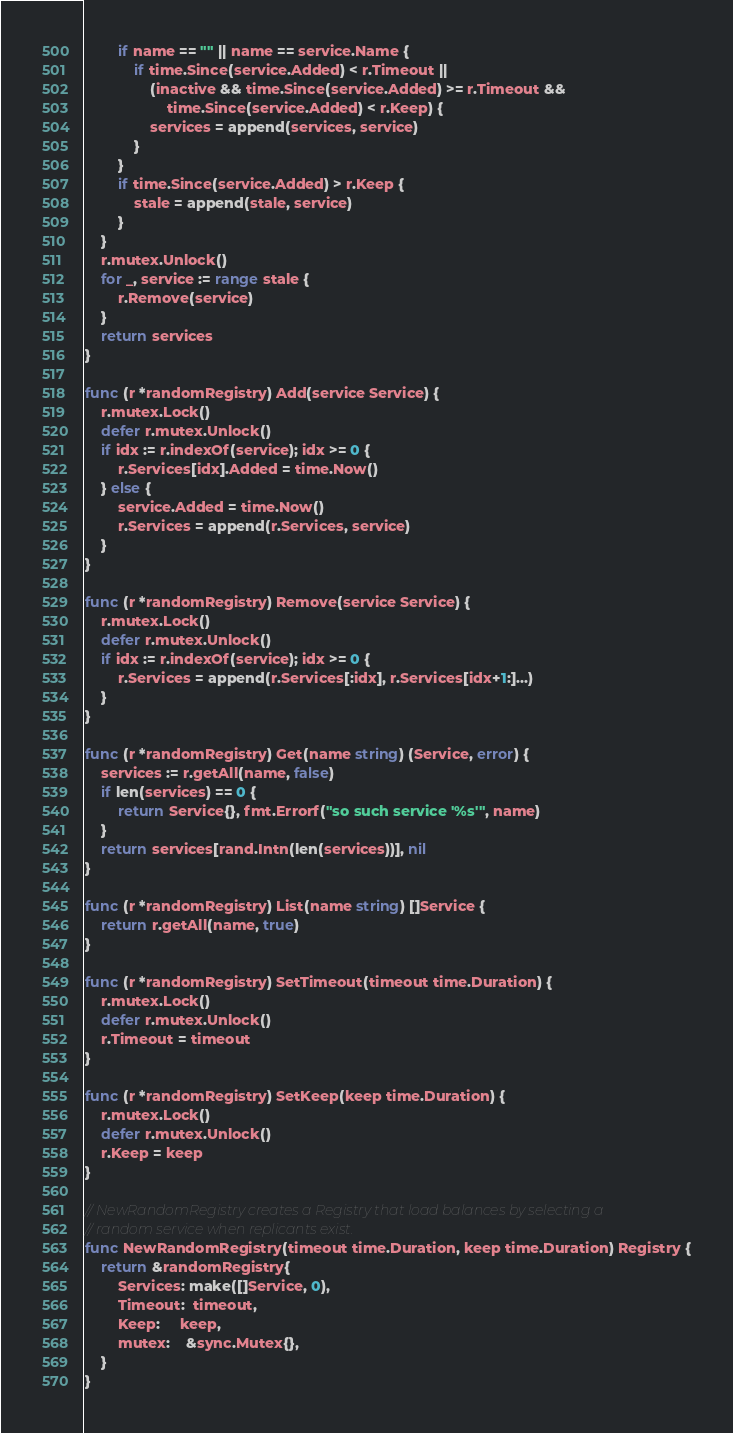<code> <loc_0><loc_0><loc_500><loc_500><_Go_>		if name == "" || name == service.Name {
			if time.Since(service.Added) < r.Timeout ||
				(inactive && time.Since(service.Added) >= r.Timeout &&
					time.Since(service.Added) < r.Keep) {
				services = append(services, service)
			}
		}
		if time.Since(service.Added) > r.Keep {
			stale = append(stale, service)
		}
	}
	r.mutex.Unlock()
	for _, service := range stale {
		r.Remove(service)
	}
	return services
}

func (r *randomRegistry) Add(service Service) {
	r.mutex.Lock()
	defer r.mutex.Unlock()
	if idx := r.indexOf(service); idx >= 0 {
		r.Services[idx].Added = time.Now()
	} else {
		service.Added = time.Now()
		r.Services = append(r.Services, service)
	}
}

func (r *randomRegistry) Remove(service Service) {
	r.mutex.Lock()
	defer r.mutex.Unlock()
	if idx := r.indexOf(service); idx >= 0 {
		r.Services = append(r.Services[:idx], r.Services[idx+1:]...)
	}
}

func (r *randomRegistry) Get(name string) (Service, error) {
	services := r.getAll(name, false)
	if len(services) == 0 {
		return Service{}, fmt.Errorf("so such service '%s'", name)
	}
	return services[rand.Intn(len(services))], nil
}

func (r *randomRegistry) List(name string) []Service {
	return r.getAll(name, true)
}

func (r *randomRegistry) SetTimeout(timeout time.Duration) {
	r.mutex.Lock()
	defer r.mutex.Unlock()
	r.Timeout = timeout
}

func (r *randomRegistry) SetKeep(keep time.Duration) {
	r.mutex.Lock()
	defer r.mutex.Unlock()
	r.Keep = keep
}

// NewRandomRegistry creates a Registry that load balances by selecting a
// random service when replicants exist.
func NewRandomRegistry(timeout time.Duration, keep time.Duration) Registry {
	return &randomRegistry{
		Services: make([]Service, 0),
		Timeout:  timeout,
		Keep:     keep,
		mutex:    &sync.Mutex{},
	}
}
</code> 